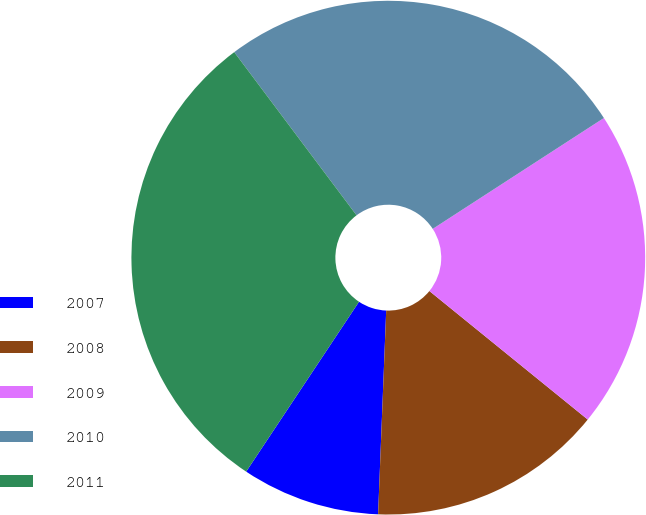<chart> <loc_0><loc_0><loc_500><loc_500><pie_chart><fcel>2007<fcel>2008<fcel>2009<fcel>2010<fcel>2011<nl><fcel>8.7%<fcel>14.78%<fcel>20.0%<fcel>26.09%<fcel>30.43%<nl></chart> 